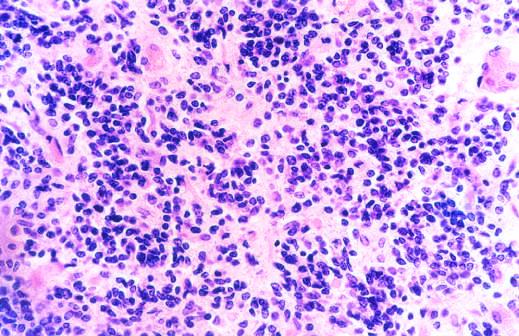did microscopic appearance of medulloblastoma show mostly small, blue, primitive-appearing tumor cells?
Answer the question using a single word or phrase. Yes 